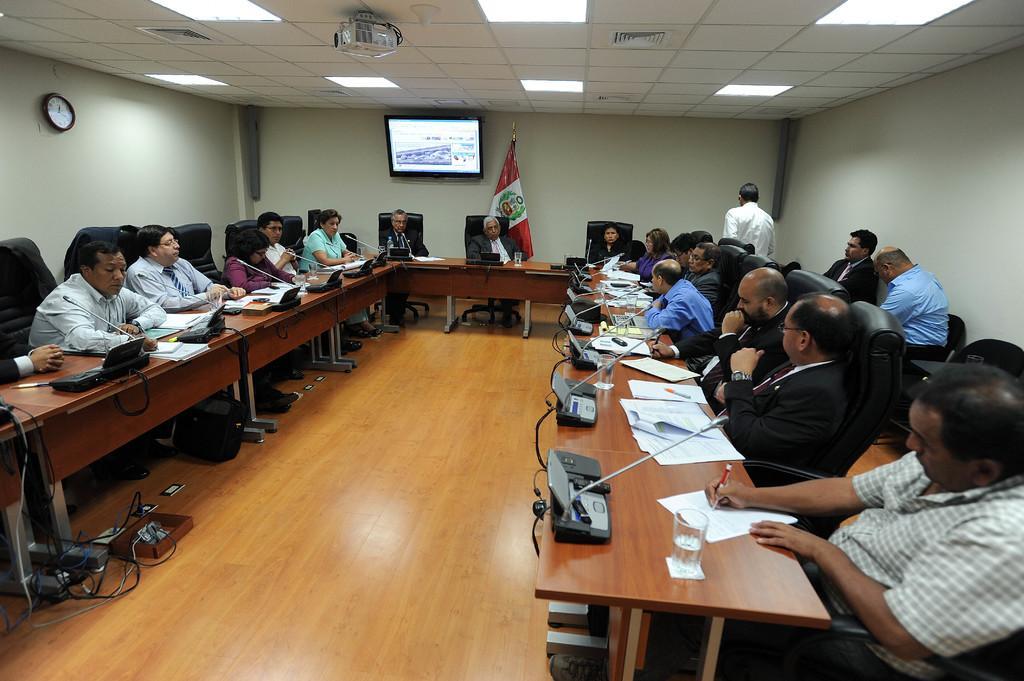In one or two sentences, can you explain what this image depicts? This picture is clicked inside the room. On the right corner there is a man wearing shirt, sitting on the chair and holding a pen and seems to be writing something on the paper. In the center we can see the group of people sitting on the chairs and there is a flag and there are some objects placed on the ground. On the right there is a person seems to be walking on the ground. In the background we can see the clock hanging on the wall and we can see the wall mounted digital screen. At the top there is a roof, ceiling lights and a projector screen. 